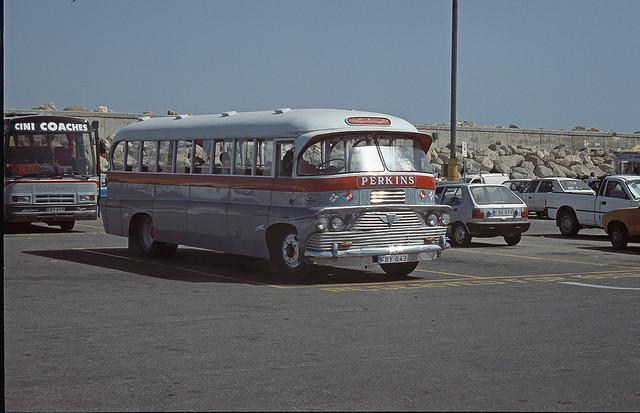What country's red white flag is on the Perkins bus? Please explain your reasoning. peru. There is a peruvian flag on top of the bus. 